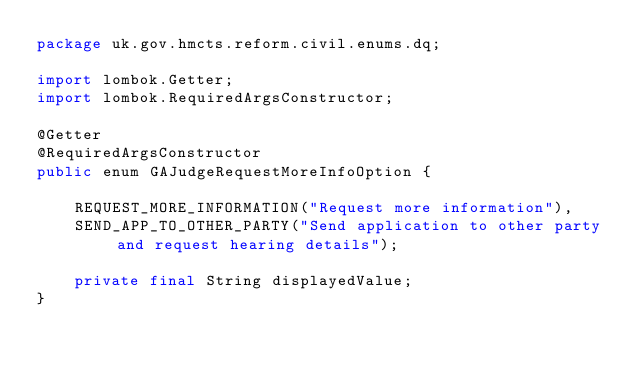Convert code to text. <code><loc_0><loc_0><loc_500><loc_500><_Java_>package uk.gov.hmcts.reform.civil.enums.dq;

import lombok.Getter;
import lombok.RequiredArgsConstructor;

@Getter
@RequiredArgsConstructor
public enum GAJudgeRequestMoreInfoOption {

    REQUEST_MORE_INFORMATION("Request more information"),
    SEND_APP_TO_OTHER_PARTY("Send application to other party and request hearing details");

    private final String displayedValue;
}
</code> 